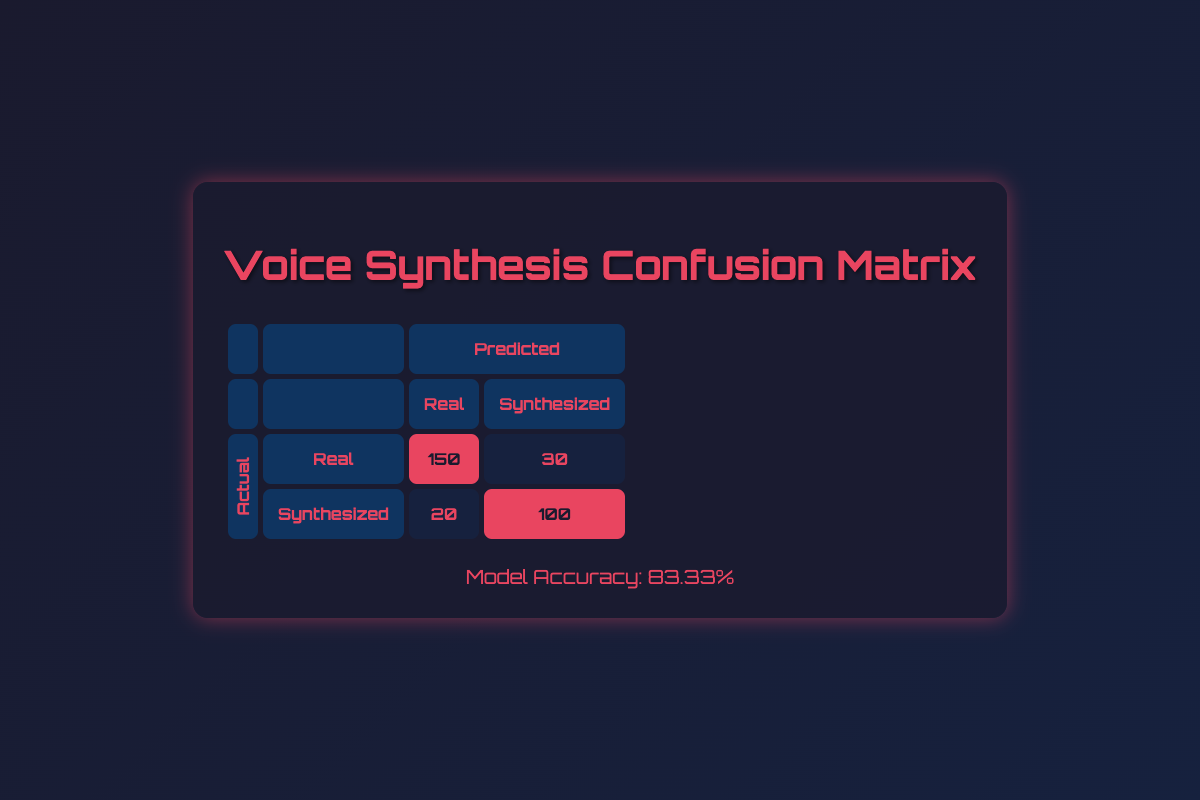What is the count of instances where the actual voice was synthesized but predicted as real? From the table, under the row for "Synthesized" actual and "Real" predicted, the count is listed as 20.
Answer: 20 What is the total number of instances for predictions made about real voices? The table shows two entries for "Real" actual: the count for "Real" predicted is 150, and "Synthesized" predicted is 30. So, the total is 150 + 30 = 180.
Answer: 180 How many total instances were predicted as synthesized? In the table, we see that for the "Synthesized" predicted, the counts are 100 for "Synthesized" actual and 20 for "Real" actual. Adding these together gives 100 + 20 = 120.
Answer: 120 Is the model more accurate in identifying real voices compared to synthesized voices? To determine this, we compare correct predictions: for "Real," it is 150, and for "Synthesized," it is 100. Since 150 > 100, the model is indeed more accurate in identifying real voices.
Answer: Yes What is the total number of incorrectly predicted instances? The incorrect predictions consist of "Real" predicted for "Synthesized" actual (30) and "Synthesized" predicted for "Real" actual (20). Thus, the total is 30 + 20 = 50.
Answer: 50 What is the proportion of real voices correctly identified compared to all actual voices? To find this, we divide the count of correctly identified real voices (150) by the total number of actual instances (150 + 30 + 20 + 100 = 300). The proportion is 150 / 300 = 0.5 or 50%.
Answer: 50% How many instances were predicted as synthesized but were actually real? When we look at the table, under the row for "Synthesized" actual and "Real" predicted, the count is 20. Thus, the number of instances of this type is 20.
Answer: 20 What is the overall model accuracy expressed as a percentage? From the given data, the correct predictions total 150 (for real) + 100 (for synthesized) = 250. The overall instances total is 300. Therefore, accuracy is (250/300) * 100 = 83.33%.
Answer: 83.33% 